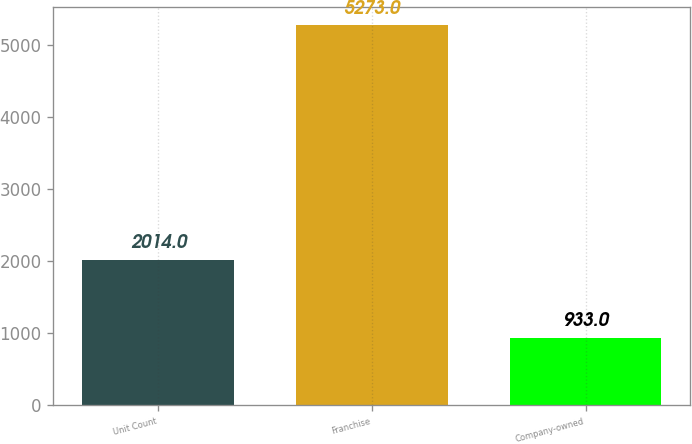Convert chart to OTSL. <chart><loc_0><loc_0><loc_500><loc_500><bar_chart><fcel>Unit Count<fcel>Franchise<fcel>Company-owned<nl><fcel>2014<fcel>5273<fcel>933<nl></chart> 